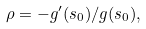Convert formula to latex. <formula><loc_0><loc_0><loc_500><loc_500>\rho = - g ^ { \prime } ( s _ { 0 } ) / g ( s _ { 0 } ) ,</formula> 